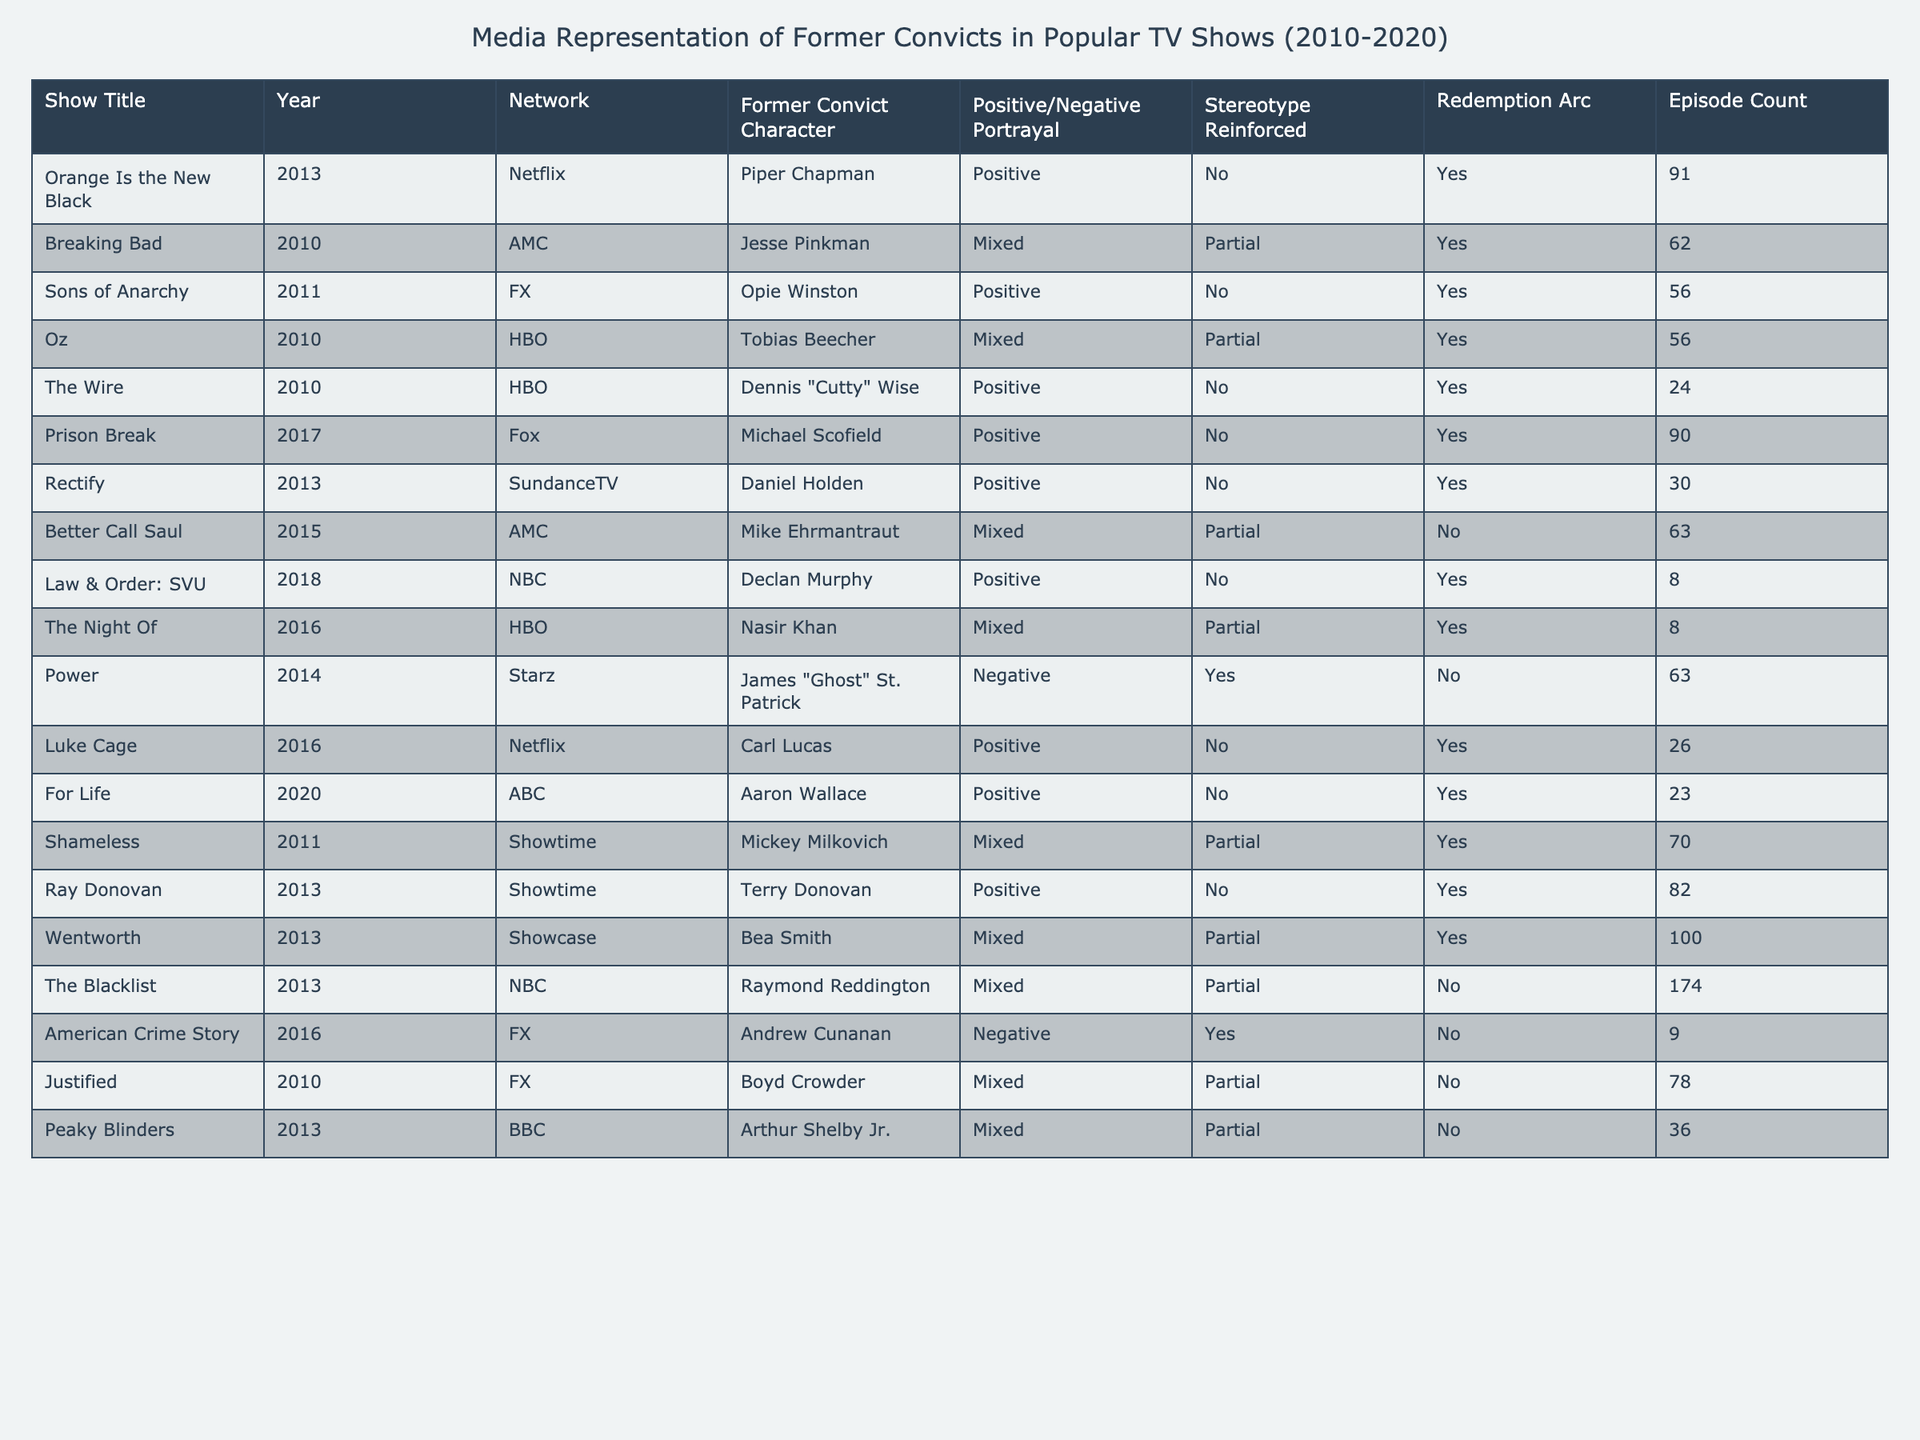What is the show with the highest episode count featuring a former convict character? The table shows that "The Blacklist" has the highest episode count of 174 episodes.
Answer: The Blacklist How many shows portray former convict characters positively? By counting the "Positive" entries under the "Positive/Negative Portrayal" column, there are 8 shows with positive portrayals of former convicts.
Answer: 8 Which character from "Breaking Bad" has a mixed portrayal? From the table, Jesse Pinkman from "Breaking Bad" is identified as having a mixed portrayal.
Answer: Jesse Pinkman Are there any series with a redemption arc for former convict characters that also have a negative portrayal? Reviewing the data, there are no shows that have both a redemption arc and a negative portrayal for a former convict character.
Answer: No What is the average number of episodes for shows that reinforce stereotypes? The shows that reinforce stereotypes (Power, American Crime Story) have episode counts of 63 and 9 respectively. The average is (63 + 9) / 2 = 36.
Answer: 36 How many shows feature former convicts without reinforcing any stereotypes? The table reveals that there are 5 shows that portray former convict characters positively and do not reinforce stereotypes: "Orange Is the New Black", "Sons of Anarchy", "The Wire", "Prison Break", and "Law & Order: SVU".
Answer: 5 Which show features the character Aaron Wallace and what is his portrayal? "For Life" features Aaron Wallace, and he is portrayed positively.
Answer: For Life, Positive What percentage of shows from the table have a mixed portrayal of former convict characters? There are 6 shows with mixed portrayals out of a total of 20 shows, so the percentage is (6 / 20) * 100 = 30%.
Answer: 30% How many of the shows listed have a redemption arc for their characters? The shows with a redemption arc are "Orange Is the New Black", "Breaking Bad", "Sons of Anarchy", "Oz", "The Wire", "Prison Break", "Rectify", "Law & Order: SVU", "The Night Of", "Luke Cage", "For Life", "Shameless", "Ray Donovan", and "Wentworth". In total, there are 13 shows that have a redemption arc.
Answer: 13 Is there any show that mixes positive portrayal with reinforcing stereotypes? Checking the table indicates that "Power" is a show that features a negative portrayal while reinforcing stereotypes, and none are identified that mix positive portrayal with reinforcing stereotypes.
Answer: No 